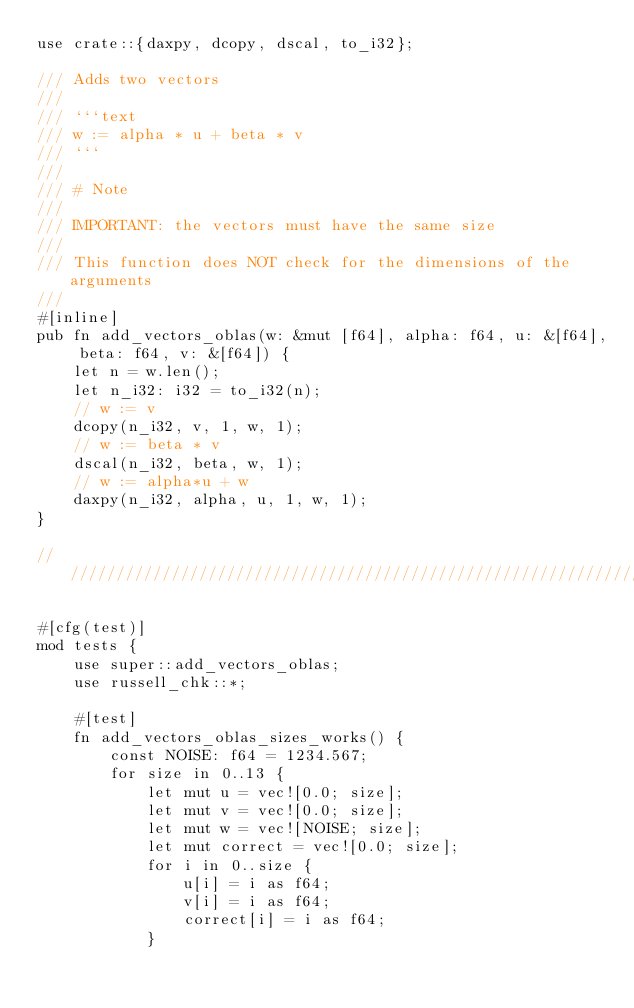Convert code to text. <code><loc_0><loc_0><loc_500><loc_500><_Rust_>use crate::{daxpy, dcopy, dscal, to_i32};

/// Adds two vectors
///
/// ```text
/// w := alpha * u + beta * v
/// ```
///
/// # Note
///
/// IMPORTANT: the vectors must have the same size
///
/// This function does NOT check for the dimensions of the arguments
///
#[inline]
pub fn add_vectors_oblas(w: &mut [f64], alpha: f64, u: &[f64], beta: f64, v: &[f64]) {
    let n = w.len();
    let n_i32: i32 = to_i32(n);
    // w := v
    dcopy(n_i32, v, 1, w, 1);
    // w := beta * v
    dscal(n_i32, beta, w, 1);
    // w := alpha*u + w
    daxpy(n_i32, alpha, u, 1, w, 1);
}

////////////////////////////////////////////////////////////////////////////////////////////////////////////////////////

#[cfg(test)]
mod tests {
    use super::add_vectors_oblas;
    use russell_chk::*;

    #[test]
    fn add_vectors_oblas_sizes_works() {
        const NOISE: f64 = 1234.567;
        for size in 0..13 {
            let mut u = vec![0.0; size];
            let mut v = vec![0.0; size];
            let mut w = vec![NOISE; size];
            let mut correct = vec![0.0; size];
            for i in 0..size {
                u[i] = i as f64;
                v[i] = i as f64;
                correct[i] = i as f64;
            }</code> 